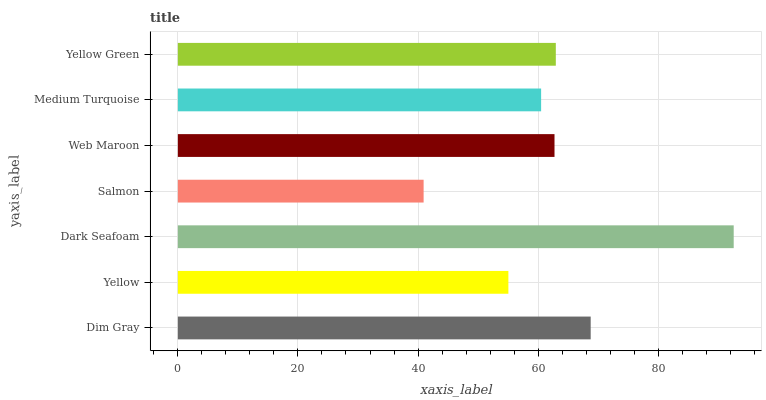Is Salmon the minimum?
Answer yes or no. Yes. Is Dark Seafoam the maximum?
Answer yes or no. Yes. Is Yellow the minimum?
Answer yes or no. No. Is Yellow the maximum?
Answer yes or no. No. Is Dim Gray greater than Yellow?
Answer yes or no. Yes. Is Yellow less than Dim Gray?
Answer yes or no. Yes. Is Yellow greater than Dim Gray?
Answer yes or no. No. Is Dim Gray less than Yellow?
Answer yes or no. No. Is Web Maroon the high median?
Answer yes or no. Yes. Is Web Maroon the low median?
Answer yes or no. Yes. Is Yellow the high median?
Answer yes or no. No. Is Dark Seafoam the low median?
Answer yes or no. No. 